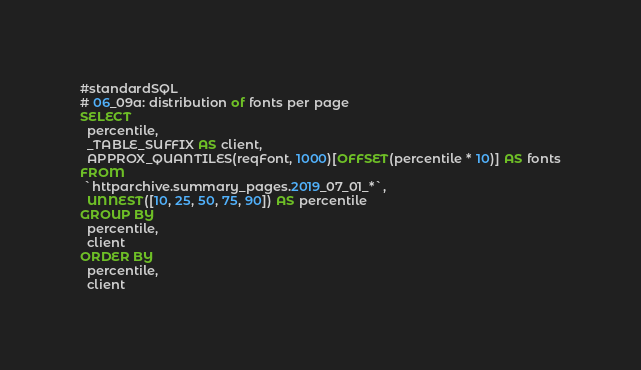<code> <loc_0><loc_0><loc_500><loc_500><_SQL_>#standardSQL
# 06_09a: distribution of fonts per page
SELECT
  percentile,
  _TABLE_SUFFIX AS client,
  APPROX_QUANTILES(reqFont, 1000)[OFFSET(percentile * 10)] AS fonts
FROM
 `httparchive.summary_pages.2019_07_01_*`,
  UNNEST([10, 25, 50, 75, 90]) AS percentile
GROUP BY
  percentile,
  client
ORDER BY
  percentile,
  client
</code> 